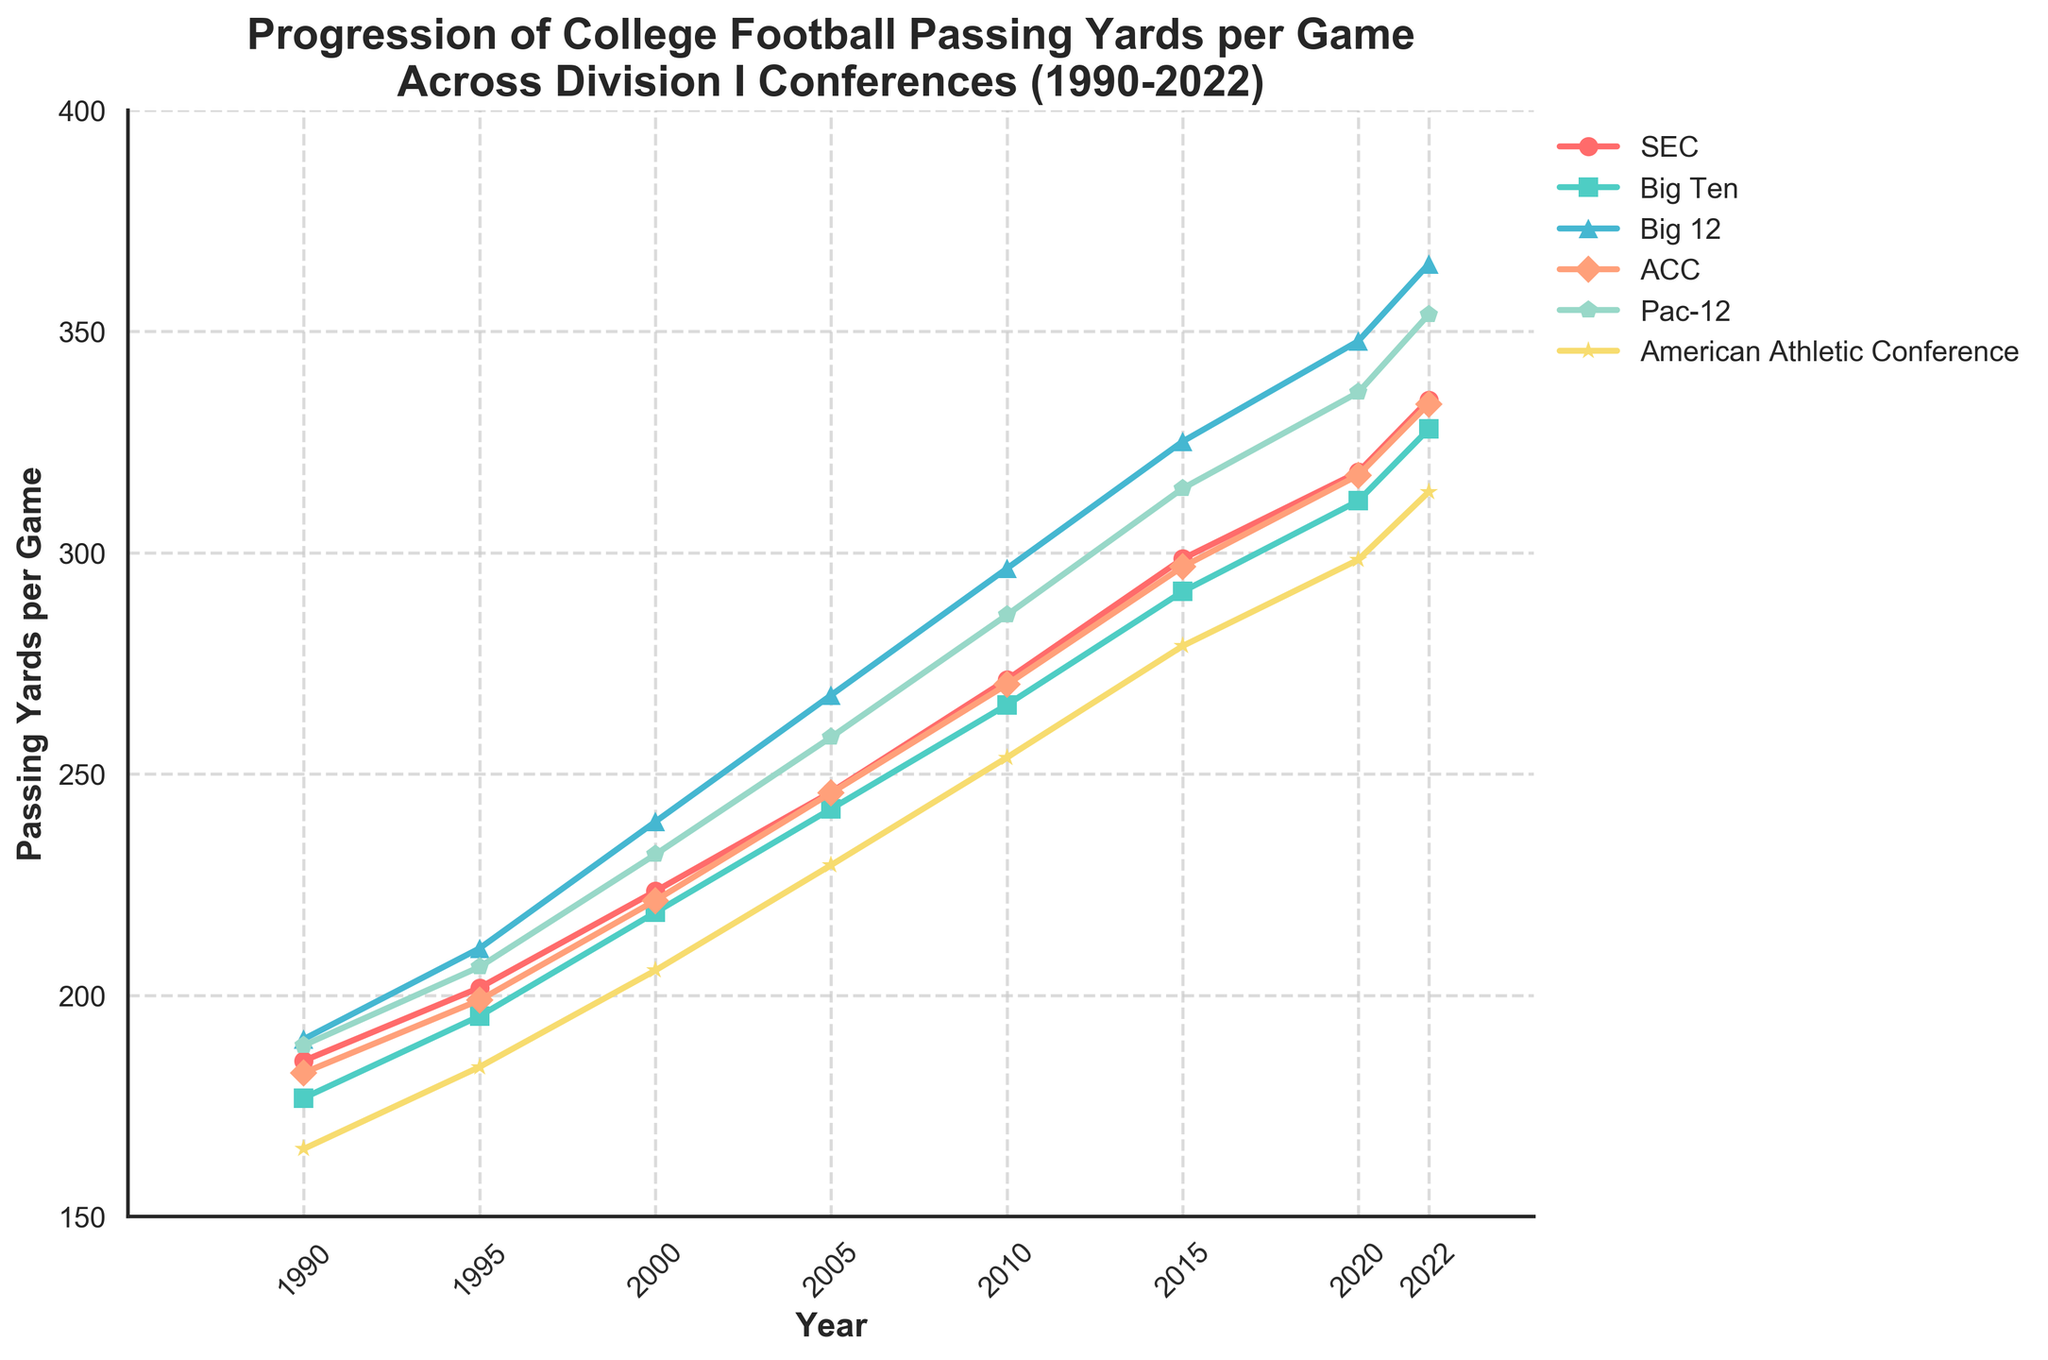what is the highest passing yards per game recorded in the SEC since 1990? The highest values in the SEC column from the data are: 185.2 (1990), 201.7 (1995), 223.5 (2000), 245.9 (2005), 271.3 (2010), 298.6 (2015), 318.2 (2020), and 334.5 (2022). The maximum value is 334.5 in 2022.
Answer: 334.5 which conference had the largest increase in passing yards per game from 1990 to 2022? Comparing the values from 1990 to 2022 for each conference: 
SEC: 334.5 - 185.2 = 149.3 
Big Ten: 327.9 - 176.8 = 151.1 
Big 12: 365.2 - 190.1 = 175.1 
ACC: 333.6 - 182.5 = 151.1 
Pac-12: 353.8 - 188.7 = 165.1 
Amer. Ath. Conf.: 313.7 - 165.3 = 148.4 
The largest increase is in the Big 12.
Answer: Big 12 In what year did the Pac-12 surpass 300 passing yards per game? The passing yards per game for Pac-12 by year are: 
188.7 (1990), 206.4 (1995), 231.8 (2000), 258.3 (2005), 285.9 (2010), 314.5 (2015), 336.2 (2020), 353.8 (2022). The Pac-12 surpassed 300 in 2015.
Answer: 2015 By how much did the ACC's passing yards per game increase from 2010 to 2020? The ACC's passing yards per game in 2010 is 270.2, and in 2020 it is 317.5. The increase is 317.5 - 270.2 = 47.3.
Answer: 47.3 Which conference had the smallest increase in passing yards per game from 2010 to 2022? Comparing the values from 2010 to 2022 for each: 
SEC: 334.5 - 271.3 = 63.2 
Big Ten: 327.9 - 265.6 = 62.3 
Big 12: 365.2 - 296.4 = 68.8 
ACC: 333.6 - 270.2 = 63.4 
Pac-12: 353.8 - 285.9 = 67.9 
Amer. Ath. Conf.: 313.7 - 253.7 = 60 
The smallest increase is in the Amer. Ath. Conf.
Answer: Amer. Ath. Conf What is the average passing yards per game for the Big Ten in the years provided? The passing yards per game for the Big Ten are: 176.8 (1990), 195.3 (1995), 218.7 (2000), 242.1 (2005), 265.6 (2010), 291.2 (2015), 311.7 (2020), and 327.9 (2022). The sum of these values is 2029.3. The number of years provided is 8, so the average is 2029.3 / 8 = 253.66.
Answer: 253.66 Which year had the highest passing yards per game overall across all conferences? Comparing the values for all conferences across all years:
For 1990, the max value is 190.1 (Big 12).
For 1995, the max value is 210.6 (Big 12).
For 2000, the max value is 239.2 (Big 12).
For 2005, the max value is 267.8 (Big 12).
For 2010, the max value is 296.4 (Big 12).
For 2015, the max value is 325.1 (Big 12).
For 2020, the max value is 347.8 (Big 12).
For 2022, the max value is 365.2 (Big 12).
The highest value overall is 365.2 in 2022.
Answer: 2022 What is the difference in passing yards per game between the Big Ten and ACC in 2022? In 2022, the Big Ten had 327.9 passing yards per game and the ACC had 333.6. The difference is 333.6 - 327.9 = 5.7.
Answer: 5.7 Which conference showed nearly linear growth over the years? Observing the trends for each conference:
The SEC, Big Ten, Big 12, ACC, Pac-12, and Amer. Ath. Conf. show increases, but the Pac-12's increase is more consistent and appears linear from the data provided.
Answer: Pac-12 